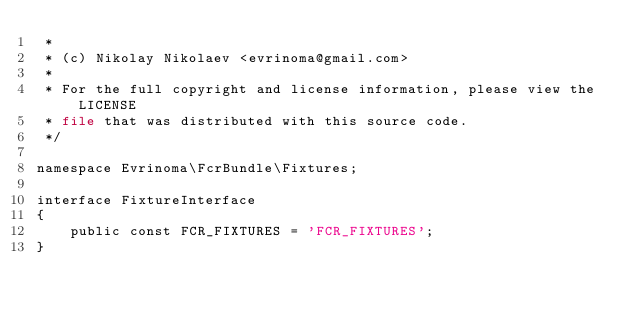<code> <loc_0><loc_0><loc_500><loc_500><_PHP_> *
 * (c) Nikolay Nikolaev <evrinoma@gmail.com>
 *
 * For the full copyright and license information, please view the LICENSE
 * file that was distributed with this source code.
 */

namespace Evrinoma\FcrBundle\Fixtures;

interface FixtureInterface
{
    public const FCR_FIXTURES = 'FCR_FIXTURES';
}
</code> 